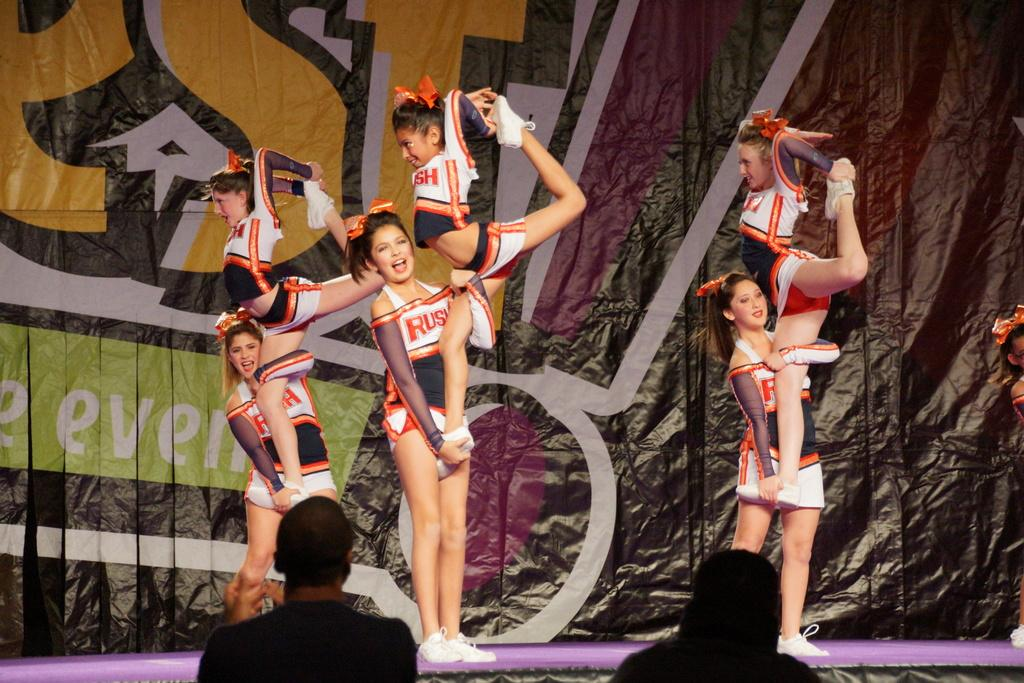What activity are the girls in the image participating in? The girls in the image are performing gymnastics. Are there any spectators in the image? Yes, there are people watching the gymnastics performance. What can be seen in the background of the image? There is a banner with text in the background of the image. What type of store can be seen in the background of the image? There is no store present in the image; it features a gymnastics performance with a banner in the background. What kind of notebook is being used by the gymnasts during their performance? There is no notebook visible in the image; the girls are performing gymnastics without any visible notebooks. 